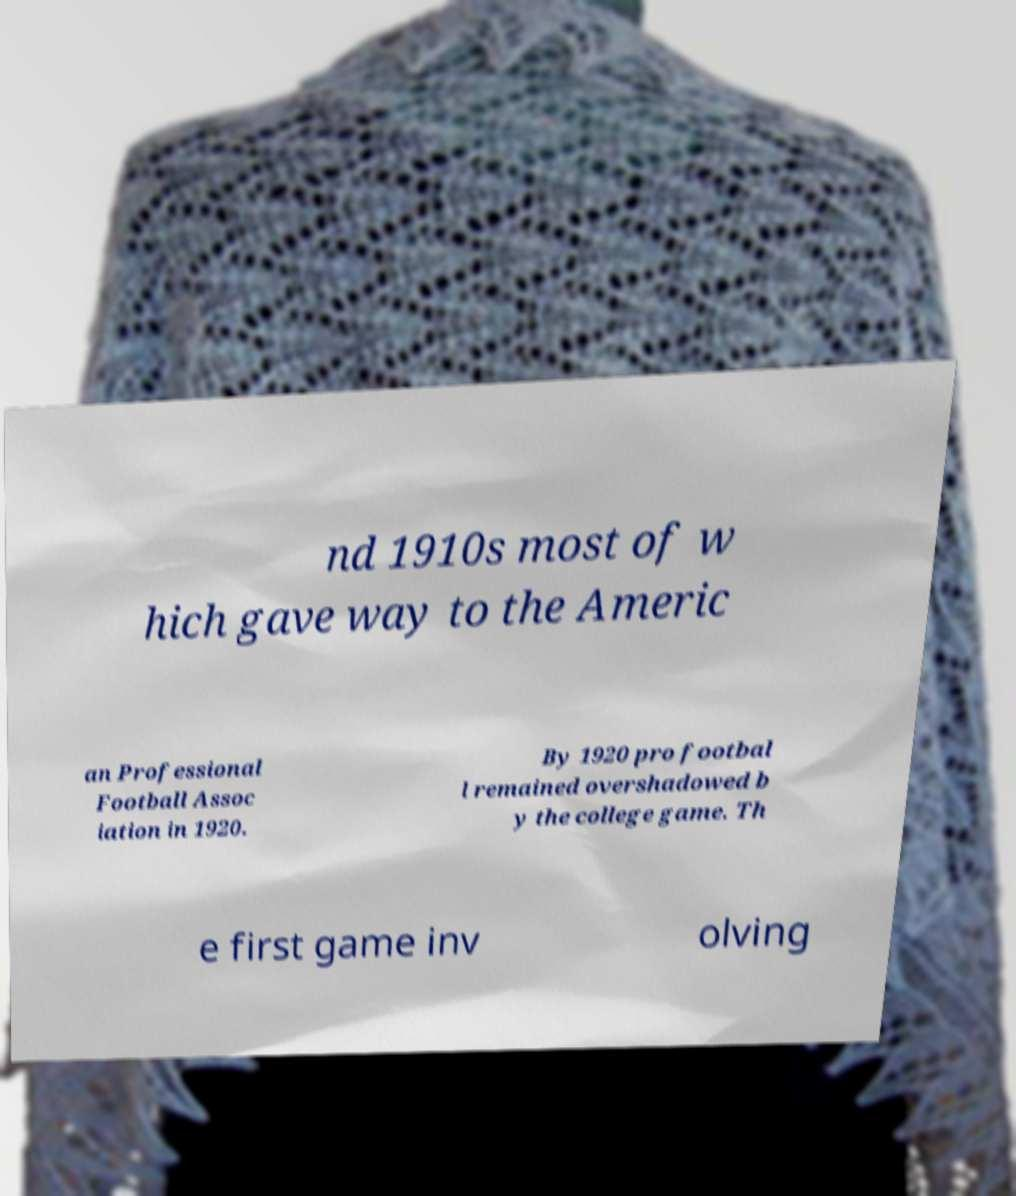Please read and relay the text visible in this image. What does it say? nd 1910s most of w hich gave way to the Americ an Professional Football Assoc iation in 1920. By 1920 pro footbal l remained overshadowed b y the college game. Th e first game inv olving 